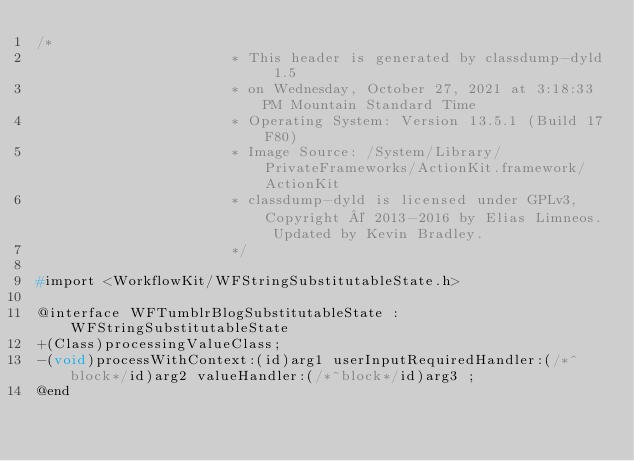<code> <loc_0><loc_0><loc_500><loc_500><_C_>/*
                       * This header is generated by classdump-dyld 1.5
                       * on Wednesday, October 27, 2021 at 3:18:33 PM Mountain Standard Time
                       * Operating System: Version 13.5.1 (Build 17F80)
                       * Image Source: /System/Library/PrivateFrameworks/ActionKit.framework/ActionKit
                       * classdump-dyld is licensed under GPLv3, Copyright © 2013-2016 by Elias Limneos. Updated by Kevin Bradley.
                       */

#import <WorkflowKit/WFStringSubstitutableState.h>

@interface WFTumblrBlogSubstitutableState : WFStringSubstitutableState
+(Class)processingValueClass;
-(void)processWithContext:(id)arg1 userInputRequiredHandler:(/*^block*/id)arg2 valueHandler:(/*^block*/id)arg3 ;
@end

</code> 